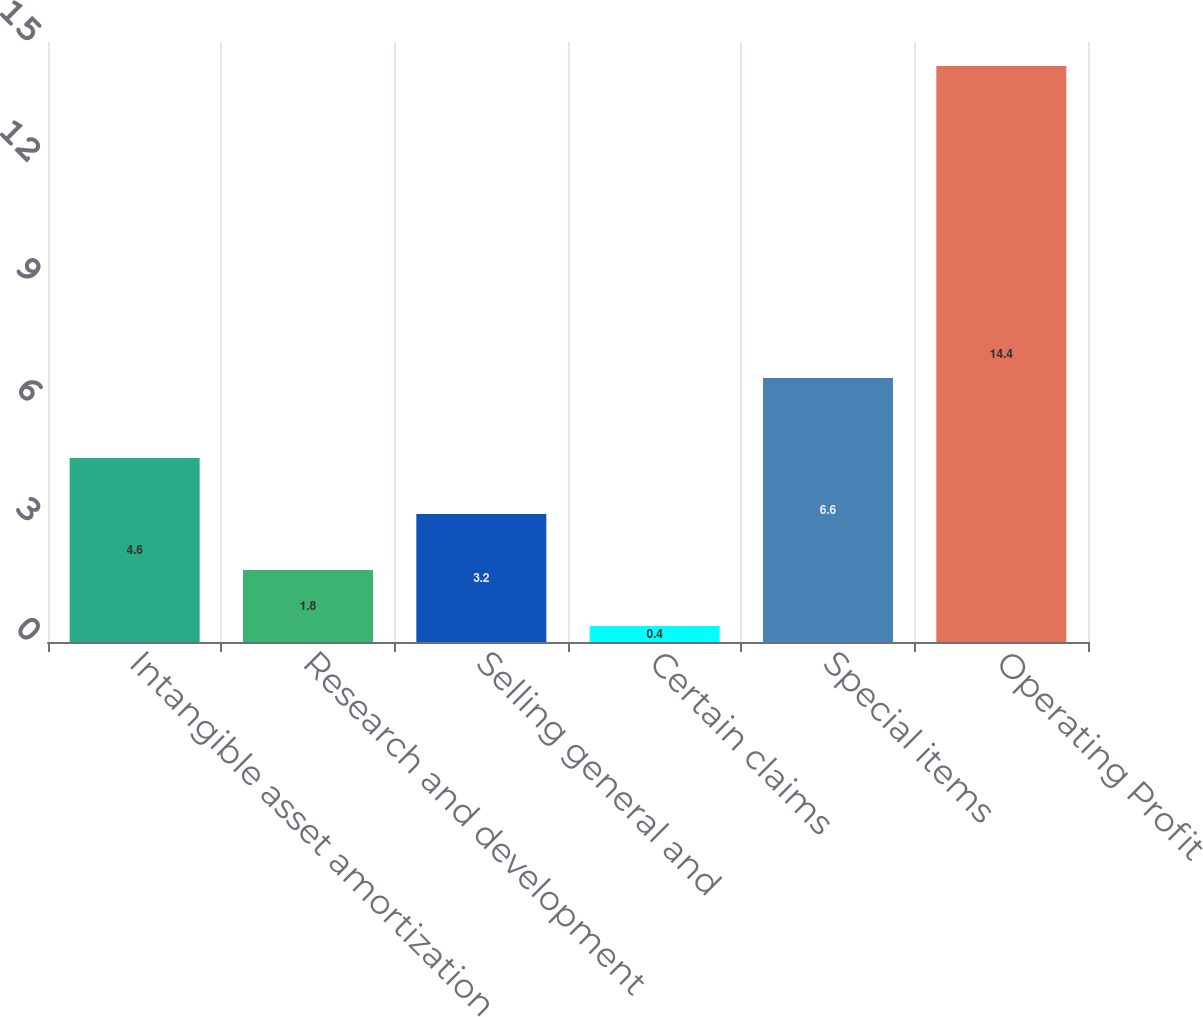<chart> <loc_0><loc_0><loc_500><loc_500><bar_chart><fcel>Intangible asset amortization<fcel>Research and development<fcel>Selling general and<fcel>Certain claims<fcel>Special items<fcel>Operating Profit<nl><fcel>4.6<fcel>1.8<fcel>3.2<fcel>0.4<fcel>6.6<fcel>14.4<nl></chart> 